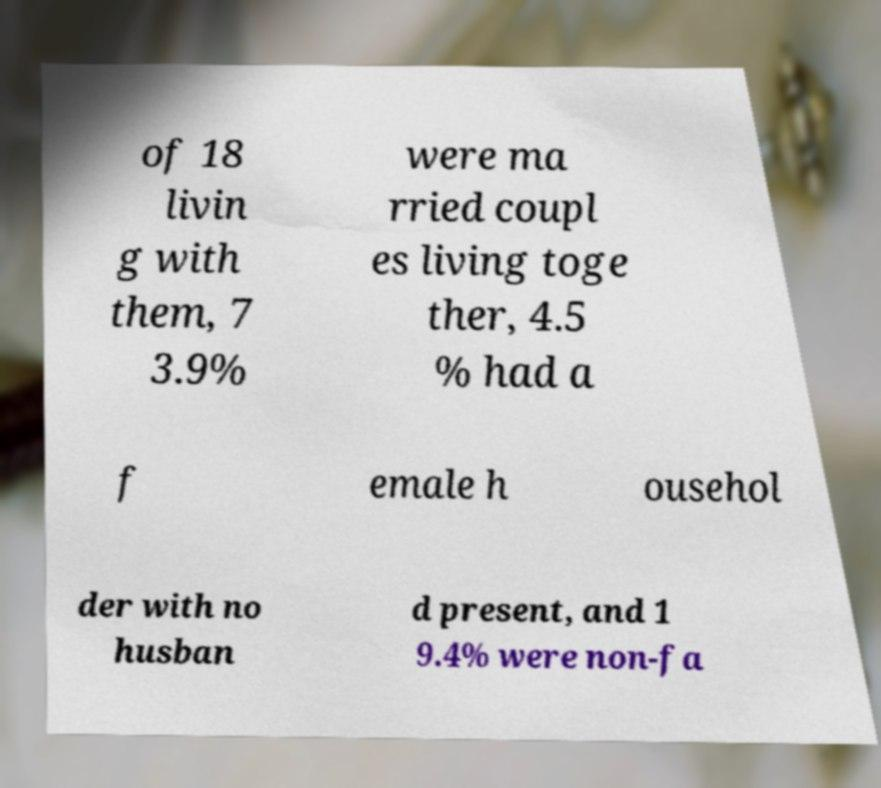Can you accurately transcribe the text from the provided image for me? of 18 livin g with them, 7 3.9% were ma rried coupl es living toge ther, 4.5 % had a f emale h ousehol der with no husban d present, and 1 9.4% were non-fa 